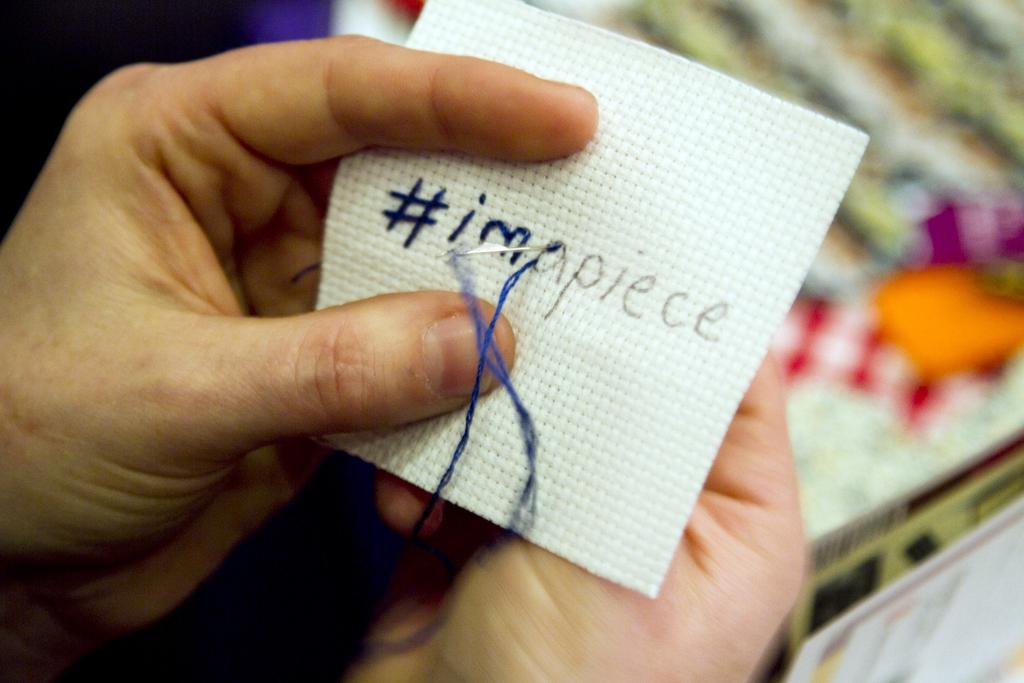What can be seen in the hands of the person in the image? There is a piece of cloth in the hands of the person in the image. What is being done to the cloth? There is a needle with thread on the cloth, suggesting that the person is sewing or mending the cloth. Can you describe the background of the image? The background of the image is blurry. What type of cushion is being used to play a game on the sofa in the image? There is no sofa, cushion, or game present in the image; it only features a person holding a piece of cloth with a needle and thread. 